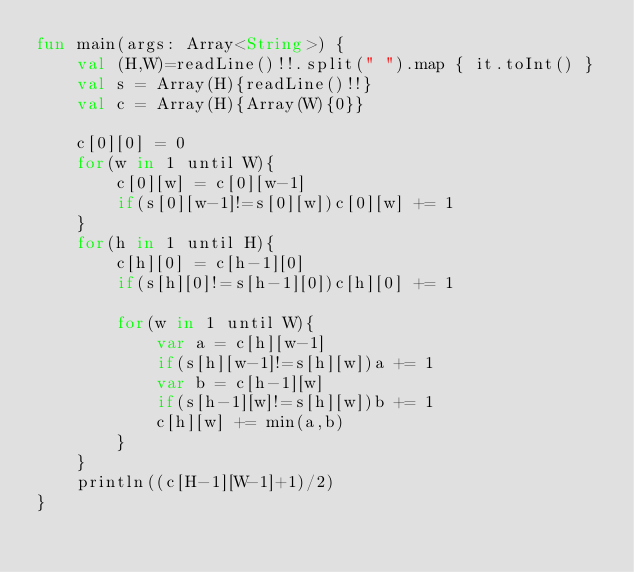Convert code to text. <code><loc_0><loc_0><loc_500><loc_500><_Kotlin_>fun main(args: Array<String>) {
    val (H,W)=readLine()!!.split(" ").map { it.toInt() }
    val s = Array(H){readLine()!!}
    val c = Array(H){Array(W){0}}
    
    c[0][0] = 0
    for(w in 1 until W){
        c[0][w] = c[0][w-1]
        if(s[0][w-1]!=s[0][w])c[0][w] += 1
    }
    for(h in 1 until H){
        c[h][0] = c[h-1][0]
        if(s[h][0]!=s[h-1][0])c[h][0] += 1

        for(w in 1 until W){
            var a = c[h][w-1]
            if(s[h][w-1]!=s[h][w])a += 1
            var b = c[h-1][w]
            if(s[h-1][w]!=s[h][w])b += 1
            c[h][w] += min(a,b)
        }
    }
    println((c[H-1][W-1]+1)/2)
}</code> 